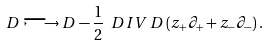Convert formula to latex. <formula><loc_0><loc_0><loc_500><loc_500>D \longmapsto D - \frac { 1 } { 2 } \ D I V { \, D } \, ( z _ { + } \partial _ { + } + z _ { - } \partial _ { - } ) \, .</formula> 